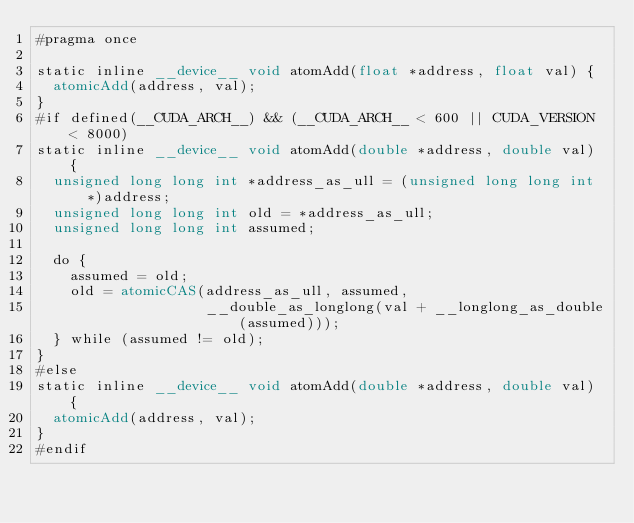<code> <loc_0><loc_0><loc_500><loc_500><_Cuda_>#pragma once

static inline __device__ void atomAdd(float *address, float val) {
  atomicAdd(address, val);
}
#if defined(__CUDA_ARCH__) && (__CUDA_ARCH__ < 600 || CUDA_VERSION < 8000)
static inline __device__ void atomAdd(double *address, double val) {
  unsigned long long int *address_as_ull = (unsigned long long int *)address;
  unsigned long long int old = *address_as_ull;
  unsigned long long int assumed;

  do {
    assumed = old;
    old = atomicCAS(address_as_ull, assumed,
                    __double_as_longlong(val + __longlong_as_double(assumed)));
  } while (assumed != old);
}
#else
static inline __device__ void atomAdd(double *address, double val) {
  atomicAdd(address, val);
}
#endif
</code> 